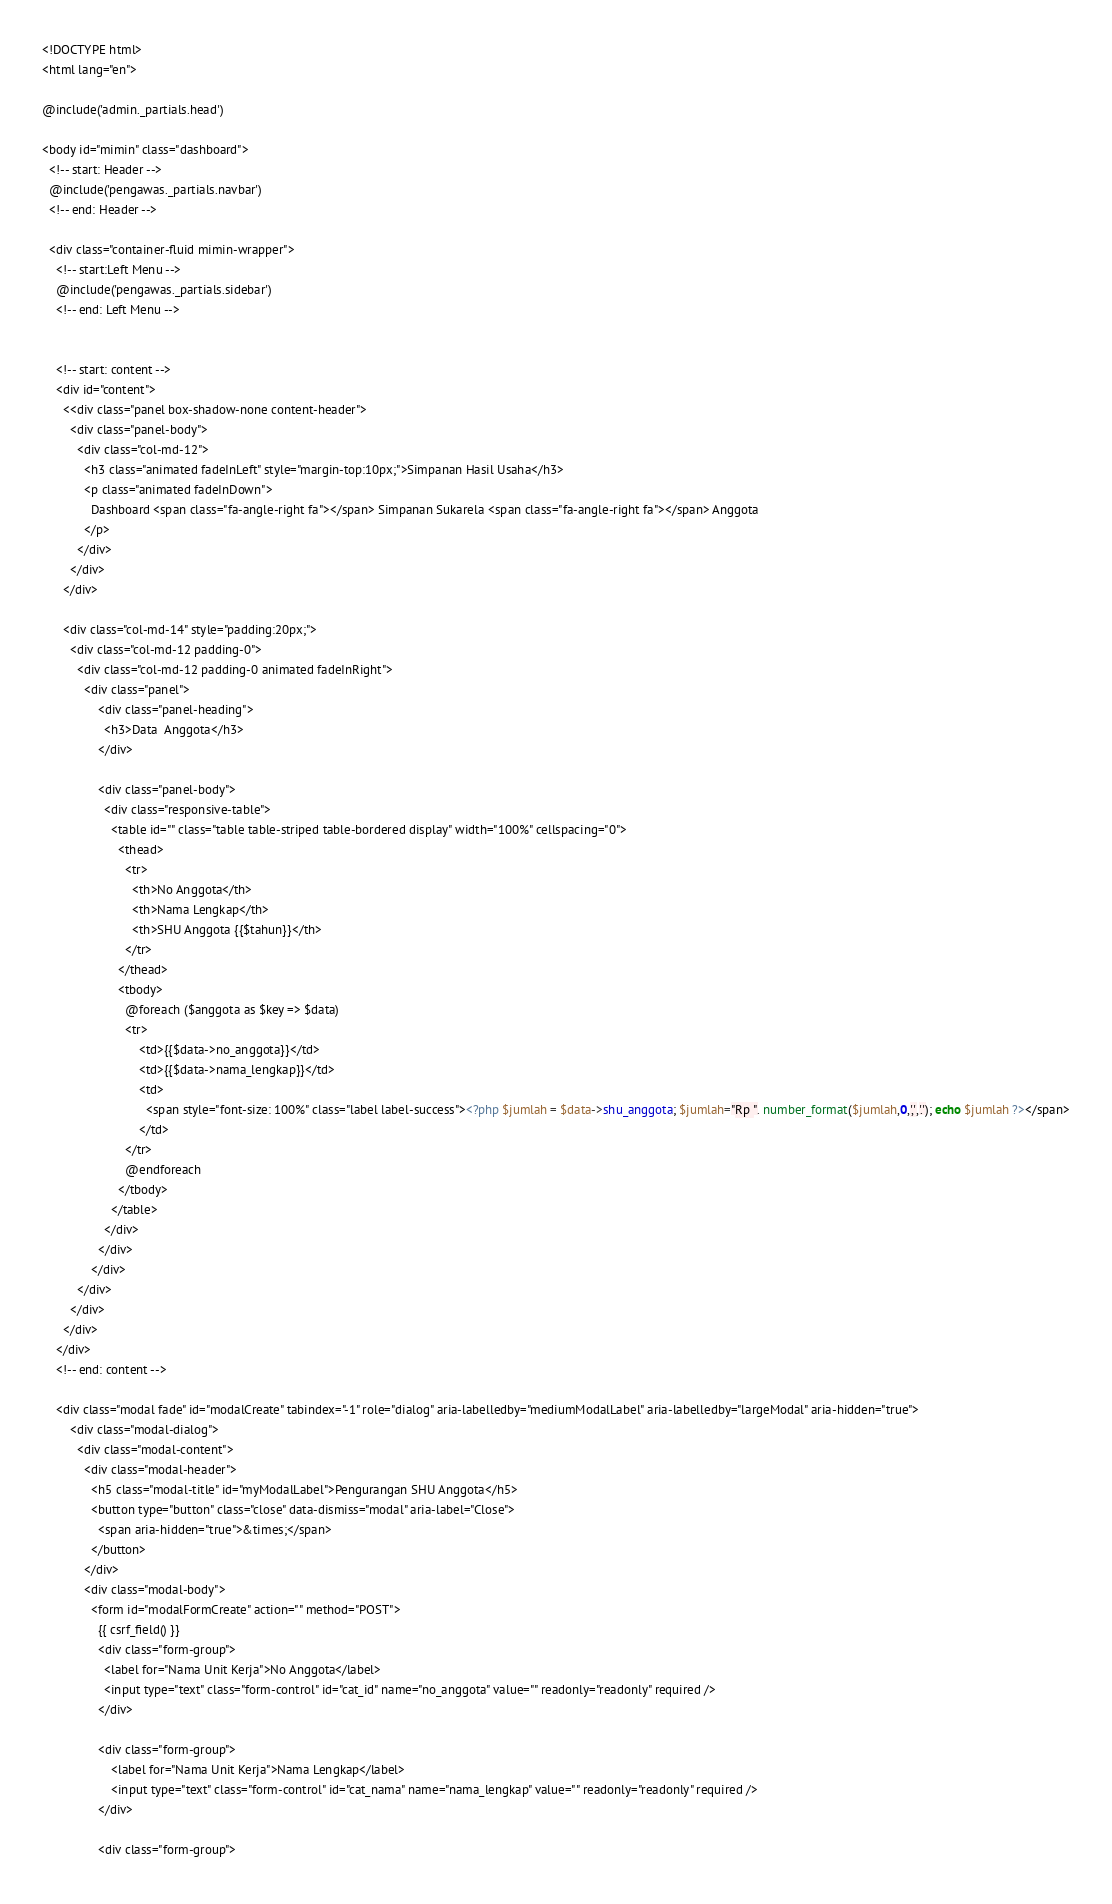<code> <loc_0><loc_0><loc_500><loc_500><_PHP_><!DOCTYPE html>
<html lang="en">

@include('admin._partials.head')

<body id="mimin" class="dashboard">
  <!-- start: Header -->
  @include('pengawas._partials.navbar')
  <!-- end: Header -->

  <div class="container-fluid mimin-wrapper">
    <!-- start:Left Menu -->
    @include('pengawas._partials.sidebar')
    <!-- end: Left Menu -->


    <!-- start: content -->
    <div id="content">
      <<div class="panel box-shadow-none content-header">
        <div class="panel-body">
          <div class="col-md-12">
            <h3 class="animated fadeInLeft" style="margin-top:10px;">Simpanan Hasil Usaha</h3>
            <p class="animated fadeInDown">
              Dashboard <span class="fa-angle-right fa"></span> Simpanan Sukarela <span class="fa-angle-right fa"></span> Anggota
            </p>
          </div>
        </div>
      </div>

      <div class="col-md-14" style="padding:20px;">
        <div class="col-md-12 padding-0">
          <div class="col-md-12 padding-0 animated fadeInRight">
            <div class="panel">
                <div class="panel-heading">
                  <h3>Data  Anggota</h3>
                </div>
                
                <div class="panel-body">
                  <div class="responsive-table">
                    <table id="" class="table table-striped table-bordered display" width="100%" cellspacing="0">
                      <thead>
                        <tr>
                          <th>No Anggota</th>
                          <th>Nama Lengkap</th>
                          <th>SHU Anggota {{$tahun}}</th>
                        </tr>
                      </thead>
                      <tbody>
                        @foreach ($anggota as $key => $data)
                        <tr>
                            <td>{{$data->no_anggota}}</td>
                            <td>{{$data->nama_lengkap}}</td>
                            <td>
                              <span style="font-size: 100%" class="label label-success"><?php $jumlah = $data->shu_anggota; $jumlah="Rp ". number_format($jumlah,0,',','.'); echo $jumlah ?></span>
                            </td>
                        </tr>
                        @endforeach
                      </tbody>
                    </table>
                  </div>
                </div>
              </div>
          </div>
        </div>
      </div>
    </div>
    <!-- end: content -->

    <div class="modal fade" id="modalCreate" tabindex="-1" role="dialog" aria-labelledby="mediumModalLabel" aria-labelledby="largeModal" aria-hidden="true">
        <div class="modal-dialog">
          <div class="modal-content">
            <div class="modal-header">
              <h5 class="modal-title" id="myModalLabel">Pengurangan SHU Anggota</h5>
              <button type="button" class="close" data-dismiss="modal" aria-label="Close">
                <span aria-hidden="true">&times;</span>
              </button>
            </div>
            <div class="modal-body">
              <form id="modalFormCreate" action="" method="POST">
                {{ csrf_field() }}
                <div class="form-group">
                  <label for="Nama Unit Kerja">No Anggota</label>
                  <input type="text" class="form-control" id="cat_id" name="no_anggota" value="" readonly="readonly" required />
                </div>

                <div class="form-group">
                    <label for="Nama Unit Kerja">Nama Lengkap</label>
                    <input type="text" class="form-control" id="cat_nama" name="nama_lengkap" value="" readonly="readonly" required />
                </div>

                <div class="form-group"></code> 